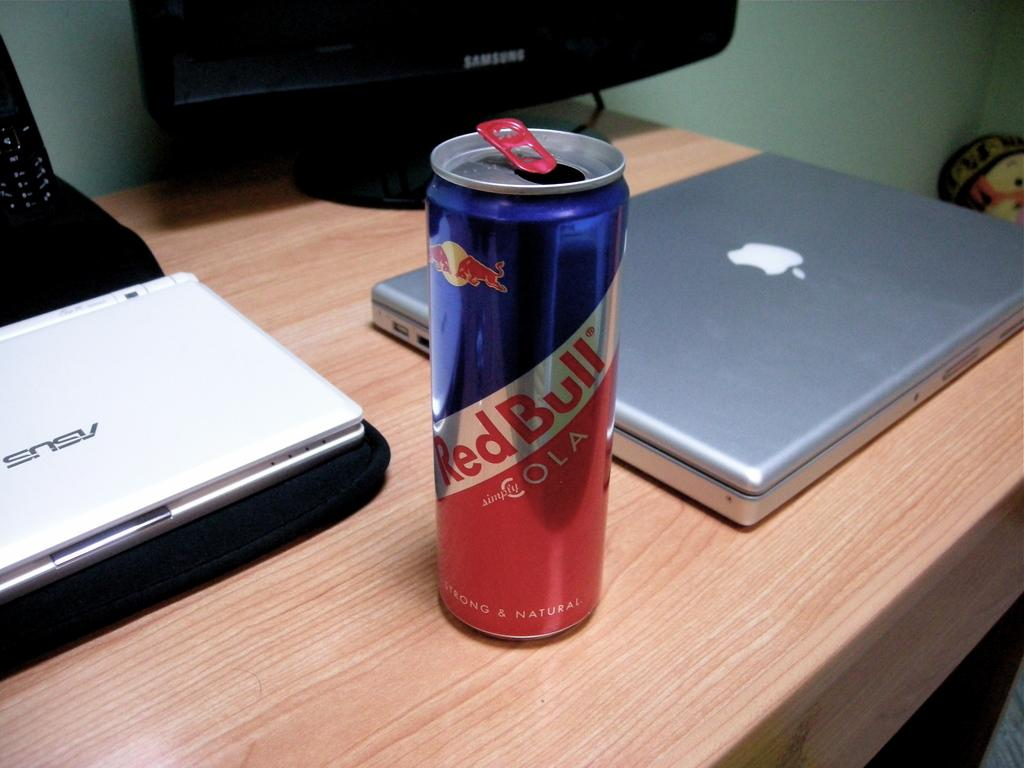<image>
Summarize the visual content of the image. A can of Red Bull sits next to a Mac and Asus laptop. 